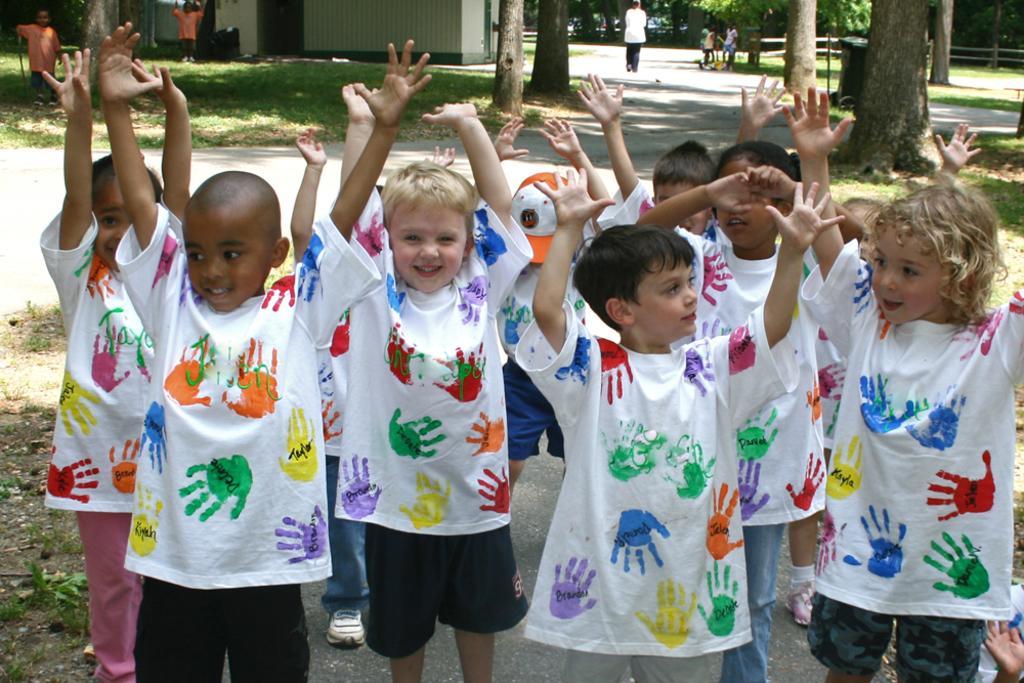How would you summarize this image in a sentence or two? In this picture there are group of people standing and raising hands. At the back there is a house and there are trees and there is a person walking on the road and there are group of people. At the bottom there is a road and there is grass. 